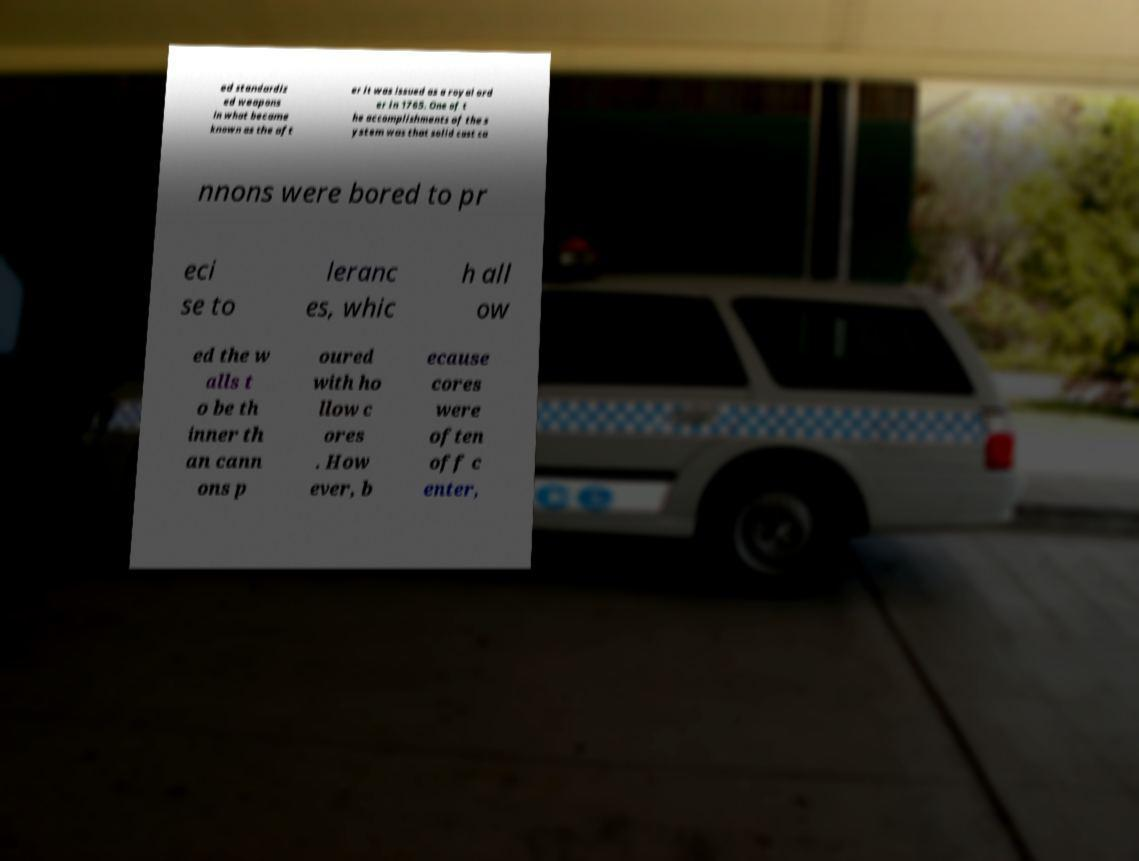Please identify and transcribe the text found in this image. ed standardiz ed weapons in what became known as the aft er it was issued as a royal ord er in 1765. One of t he accomplishments of the s ystem was that solid cast ca nnons were bored to pr eci se to leranc es, whic h all ow ed the w alls t o be th inner th an cann ons p oured with ho llow c ores . How ever, b ecause cores were often off c enter, 